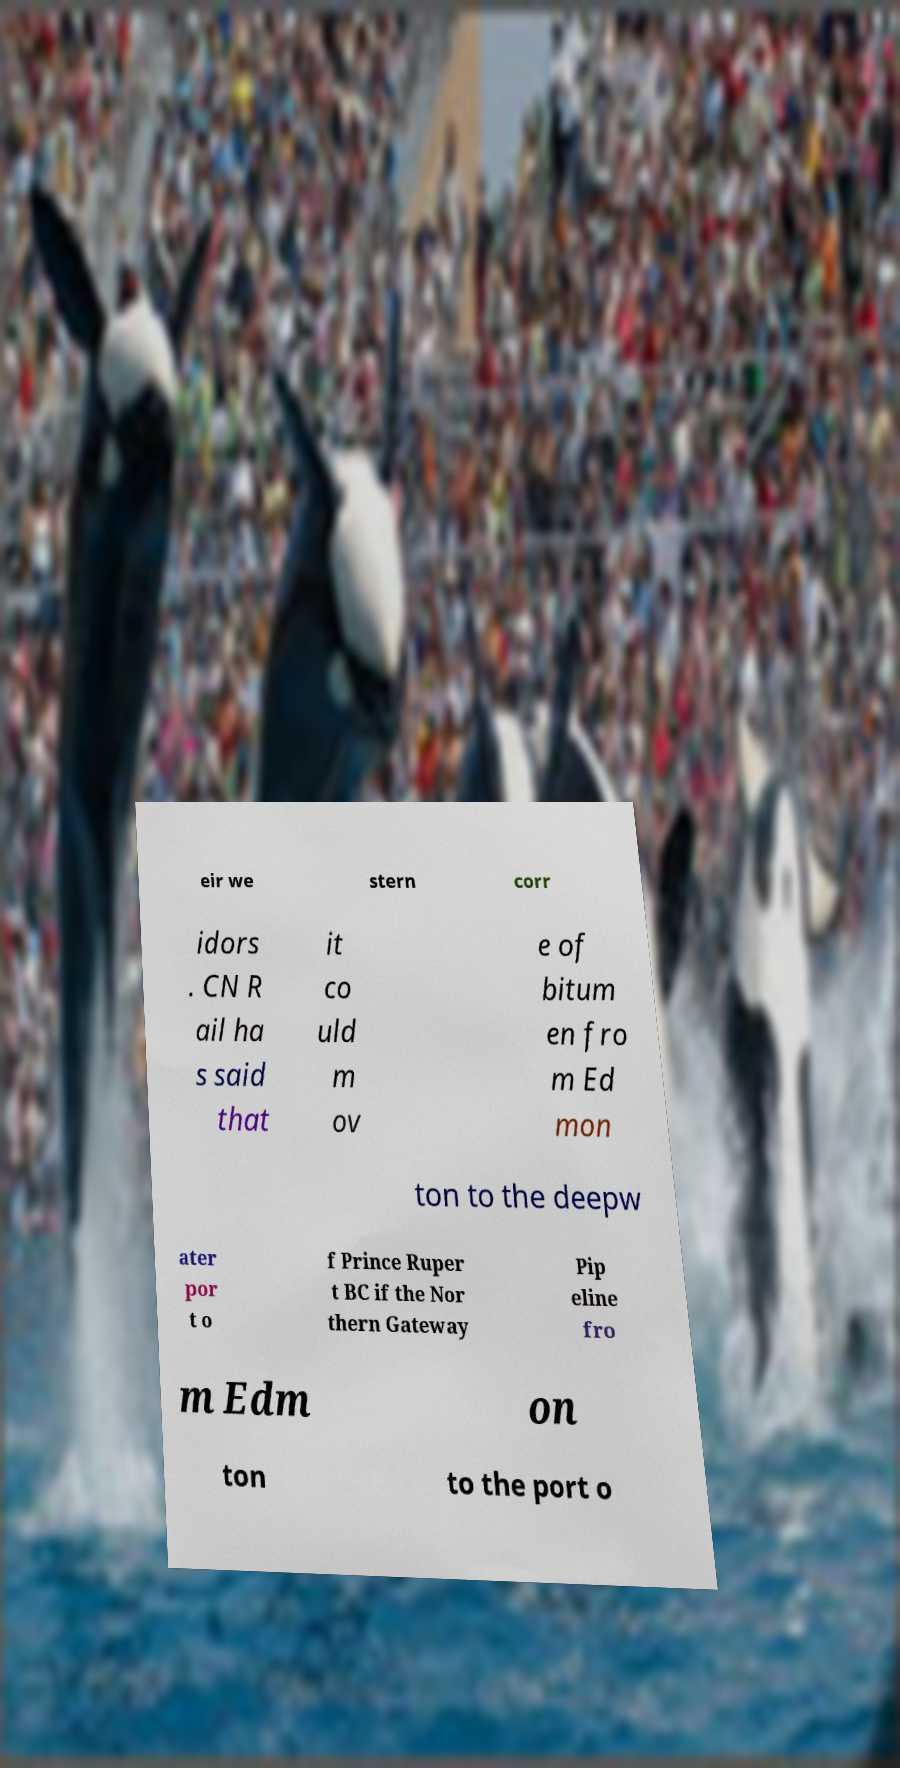Could you extract and type out the text from this image? eir we stern corr idors . CN R ail ha s said that it co uld m ov e of bitum en fro m Ed mon ton to the deepw ater por t o f Prince Ruper t BC if the Nor thern Gateway Pip eline fro m Edm on ton to the port o 